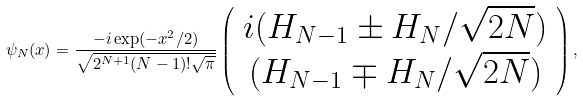Convert formula to latex. <formula><loc_0><loc_0><loc_500><loc_500>\psi _ { N } ( x ) = \frac { - i \exp ( - x ^ { 2 } / 2 ) } { \sqrt { 2 ^ { N + 1 } ( N - 1 ) ! \sqrt { \pi } } } \left ( \begin{array} { c } i ( H _ { N - 1 } \pm H _ { N } / \sqrt { 2 N } ) \\ ( H _ { N - 1 } \mp H _ { N } / \sqrt { 2 N } ) \end{array} \right ) ,</formula> 